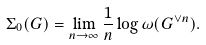Convert formula to latex. <formula><loc_0><loc_0><loc_500><loc_500>\Sigma _ { 0 } ( G ) = \lim _ { n \to \infty } \frac { 1 } { n } \log \omega ( G ^ { \vee n } ) .</formula> 